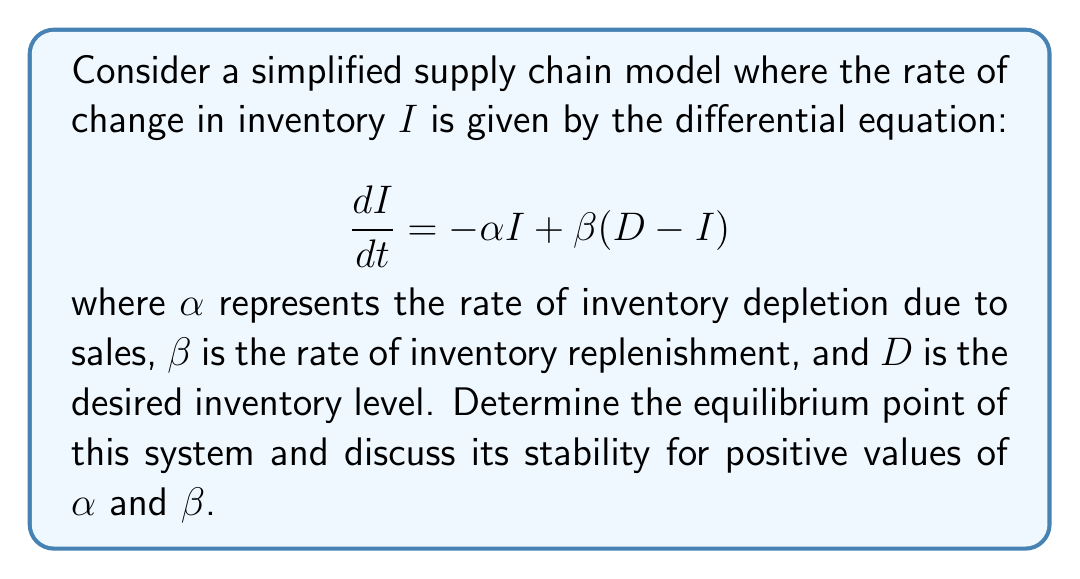Provide a solution to this math problem. To find the equilibrium point of this system, we need to follow these steps:

1) At equilibrium, the rate of change in inventory is zero. So, we set $\frac{dI}{dt} = 0$:

   $$0 = -\alpha I + \beta(D - I)$$

2) Expand the equation:

   $$0 = -\alpha I + \beta D - \beta I$$

3) Collect terms with $I$:

   $$0 = -(\alpha + \beta)I + \beta D$$

4) Solve for $I$:

   $$(\alpha + \beta)I = \beta D$$
   $$I = \frac{\beta D}{\alpha + \beta}$$

5) This is the equilibrium point. To analyze stability, we can look at the derivative of $\frac{dI}{dt}$ with respect to $I$:

   $$\frac{d}{dI}\left(\frac{dI}{dt}\right) = -\alpha - \beta$$

6) For stability, this derivative should be negative. Since $\alpha$ and $\beta$ are positive, $-(\alpha + \beta)$ is always negative.

Therefore, the equilibrium point is stable for all positive values of $\alpha$ and $\beta$. This means that the inventory will always tend towards this equilibrium level over time, regardless of the initial inventory level.
Answer: Equilibrium point: $I^* = \frac{\beta D}{\alpha + \beta}$, stable for all positive $\alpha$ and $\beta$. 